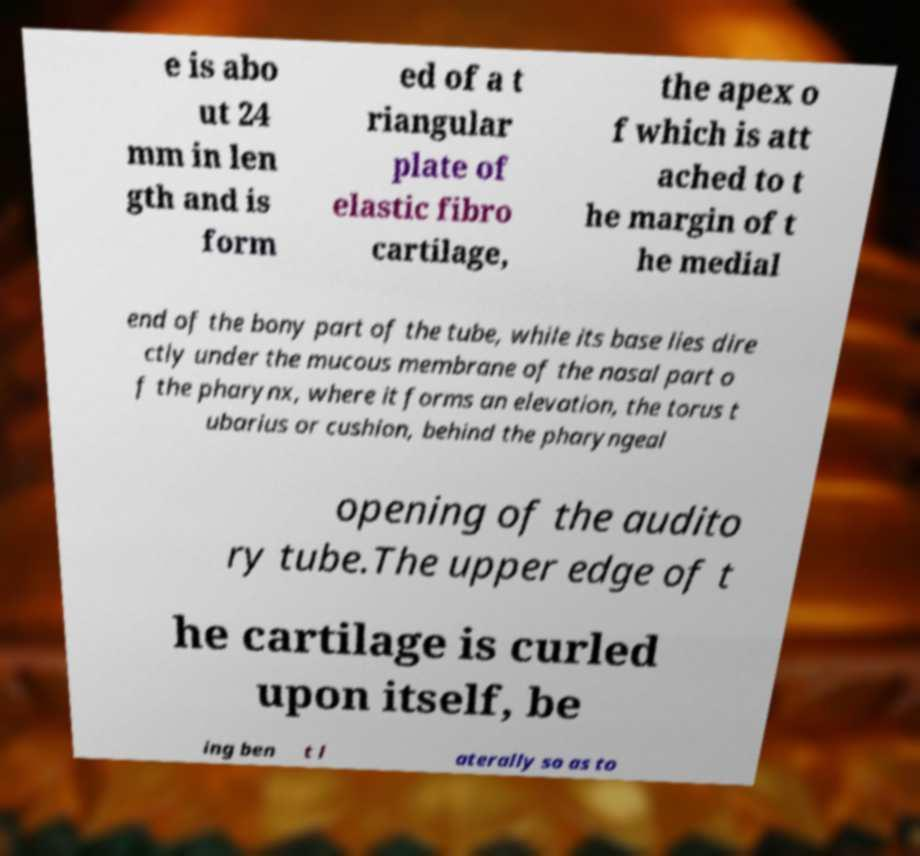What messages or text are displayed in this image? I need them in a readable, typed format. e is abo ut 24 mm in len gth and is form ed of a t riangular plate of elastic fibro cartilage, the apex o f which is att ached to t he margin of t he medial end of the bony part of the tube, while its base lies dire ctly under the mucous membrane of the nasal part o f the pharynx, where it forms an elevation, the torus t ubarius or cushion, behind the pharyngeal opening of the audito ry tube.The upper edge of t he cartilage is curled upon itself, be ing ben t l aterally so as to 